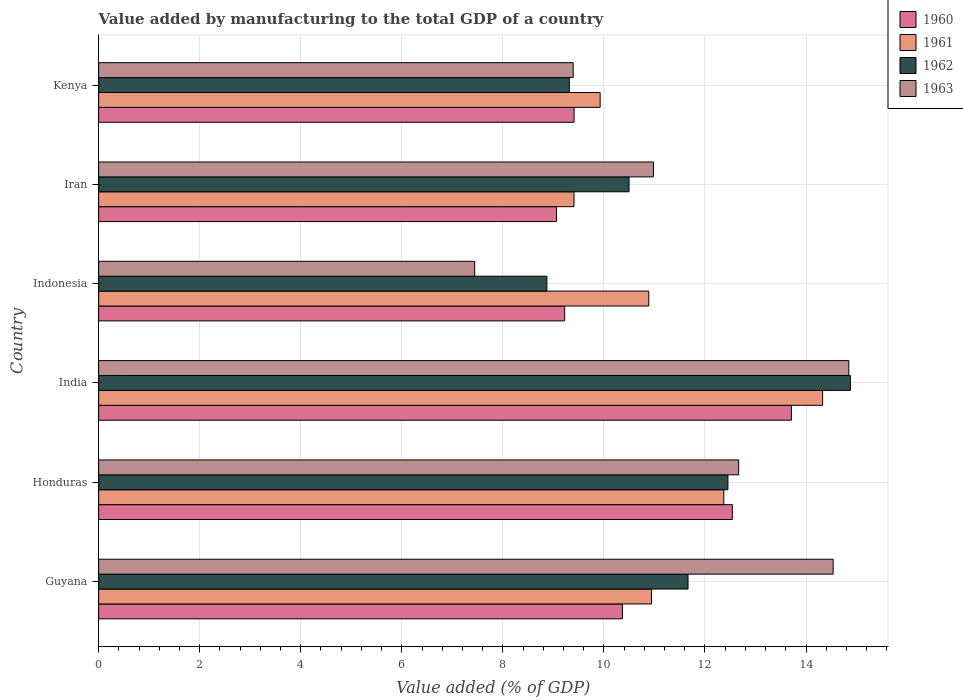How many different coloured bars are there?
Provide a short and direct response. 4. Are the number of bars per tick equal to the number of legend labels?
Offer a terse response. Yes. Are the number of bars on each tick of the Y-axis equal?
Provide a succinct answer. Yes. How many bars are there on the 6th tick from the bottom?
Your response must be concise. 4. What is the label of the 6th group of bars from the top?
Keep it short and to the point. Guyana. What is the value added by manufacturing to the total GDP in 1960 in Iran?
Your response must be concise. 9.06. Across all countries, what is the maximum value added by manufacturing to the total GDP in 1962?
Your answer should be very brief. 14.88. Across all countries, what is the minimum value added by manufacturing to the total GDP in 1961?
Your response must be concise. 9.41. In which country was the value added by manufacturing to the total GDP in 1961 maximum?
Make the answer very short. India. In which country was the value added by manufacturing to the total GDP in 1960 minimum?
Offer a terse response. Iran. What is the total value added by manufacturing to the total GDP in 1961 in the graph?
Provide a succinct answer. 67.86. What is the difference between the value added by manufacturing to the total GDP in 1961 in Honduras and that in Kenya?
Give a very brief answer. 2.45. What is the difference between the value added by manufacturing to the total GDP in 1960 in Kenya and the value added by manufacturing to the total GDP in 1962 in Iran?
Provide a succinct answer. -1.09. What is the average value added by manufacturing to the total GDP in 1962 per country?
Keep it short and to the point. 11.28. What is the difference between the value added by manufacturing to the total GDP in 1961 and value added by manufacturing to the total GDP in 1963 in India?
Offer a very short reply. -0.52. In how many countries, is the value added by manufacturing to the total GDP in 1962 greater than 8.4 %?
Provide a succinct answer. 6. What is the ratio of the value added by manufacturing to the total GDP in 1960 in India to that in Kenya?
Your answer should be compact. 1.46. Is the difference between the value added by manufacturing to the total GDP in 1961 in Honduras and India greater than the difference between the value added by manufacturing to the total GDP in 1963 in Honduras and India?
Offer a very short reply. Yes. What is the difference between the highest and the second highest value added by manufacturing to the total GDP in 1960?
Your answer should be very brief. 1.17. What is the difference between the highest and the lowest value added by manufacturing to the total GDP in 1961?
Provide a short and direct response. 4.92. Is the sum of the value added by manufacturing to the total GDP in 1960 in Guyana and Iran greater than the maximum value added by manufacturing to the total GDP in 1963 across all countries?
Provide a succinct answer. Yes. What does the 4th bar from the top in Guyana represents?
Provide a short and direct response. 1960. How many countries are there in the graph?
Ensure brevity in your answer.  6. What is the difference between two consecutive major ticks on the X-axis?
Provide a short and direct response. 2. Does the graph contain any zero values?
Provide a short and direct response. No. How many legend labels are there?
Make the answer very short. 4. How are the legend labels stacked?
Your answer should be very brief. Vertical. What is the title of the graph?
Give a very brief answer. Value added by manufacturing to the total GDP of a country. Does "2007" appear as one of the legend labels in the graph?
Make the answer very short. No. What is the label or title of the X-axis?
Your response must be concise. Value added (% of GDP). What is the label or title of the Y-axis?
Give a very brief answer. Country. What is the Value added (% of GDP) in 1960 in Guyana?
Your answer should be very brief. 10.37. What is the Value added (% of GDP) in 1961 in Guyana?
Your answer should be very brief. 10.94. What is the Value added (% of GDP) in 1962 in Guyana?
Provide a succinct answer. 11.66. What is the Value added (% of GDP) in 1963 in Guyana?
Provide a short and direct response. 14.54. What is the Value added (% of GDP) of 1960 in Honduras?
Ensure brevity in your answer.  12.54. What is the Value added (% of GDP) of 1961 in Honduras?
Give a very brief answer. 12.37. What is the Value added (% of GDP) of 1962 in Honduras?
Ensure brevity in your answer.  12.45. What is the Value added (% of GDP) of 1963 in Honduras?
Give a very brief answer. 12.67. What is the Value added (% of GDP) of 1960 in India?
Keep it short and to the point. 13.71. What is the Value added (% of GDP) in 1961 in India?
Give a very brief answer. 14.33. What is the Value added (% of GDP) in 1962 in India?
Provide a succinct answer. 14.88. What is the Value added (% of GDP) in 1963 in India?
Your answer should be very brief. 14.85. What is the Value added (% of GDP) in 1960 in Indonesia?
Make the answer very short. 9.22. What is the Value added (% of GDP) in 1961 in Indonesia?
Give a very brief answer. 10.89. What is the Value added (% of GDP) in 1962 in Indonesia?
Your response must be concise. 8.87. What is the Value added (% of GDP) of 1963 in Indonesia?
Ensure brevity in your answer.  7.44. What is the Value added (% of GDP) of 1960 in Iran?
Provide a succinct answer. 9.06. What is the Value added (% of GDP) in 1961 in Iran?
Ensure brevity in your answer.  9.41. What is the Value added (% of GDP) in 1962 in Iran?
Ensure brevity in your answer.  10.5. What is the Value added (% of GDP) in 1963 in Iran?
Offer a terse response. 10.98. What is the Value added (% of GDP) in 1960 in Kenya?
Your answer should be compact. 9.41. What is the Value added (% of GDP) of 1961 in Kenya?
Offer a terse response. 9.93. What is the Value added (% of GDP) of 1962 in Kenya?
Offer a very short reply. 9.32. What is the Value added (% of GDP) in 1963 in Kenya?
Keep it short and to the point. 9.39. Across all countries, what is the maximum Value added (% of GDP) of 1960?
Your response must be concise. 13.71. Across all countries, what is the maximum Value added (% of GDP) in 1961?
Ensure brevity in your answer.  14.33. Across all countries, what is the maximum Value added (% of GDP) of 1962?
Your answer should be compact. 14.88. Across all countries, what is the maximum Value added (% of GDP) of 1963?
Give a very brief answer. 14.85. Across all countries, what is the minimum Value added (% of GDP) in 1960?
Keep it short and to the point. 9.06. Across all countries, what is the minimum Value added (% of GDP) in 1961?
Your response must be concise. 9.41. Across all countries, what is the minimum Value added (% of GDP) of 1962?
Provide a short and direct response. 8.87. Across all countries, what is the minimum Value added (% of GDP) of 1963?
Provide a short and direct response. 7.44. What is the total Value added (% of GDP) in 1960 in the graph?
Ensure brevity in your answer.  64.31. What is the total Value added (% of GDP) of 1961 in the graph?
Your answer should be compact. 67.86. What is the total Value added (% of GDP) in 1962 in the graph?
Give a very brief answer. 67.68. What is the total Value added (% of GDP) in 1963 in the graph?
Offer a terse response. 69.86. What is the difference between the Value added (% of GDP) of 1960 in Guyana and that in Honduras?
Your response must be concise. -2.18. What is the difference between the Value added (% of GDP) of 1961 in Guyana and that in Honduras?
Provide a succinct answer. -1.43. What is the difference between the Value added (% of GDP) in 1962 in Guyana and that in Honduras?
Offer a terse response. -0.79. What is the difference between the Value added (% of GDP) of 1963 in Guyana and that in Honduras?
Offer a very short reply. 1.87. What is the difference between the Value added (% of GDP) of 1960 in Guyana and that in India?
Give a very brief answer. -3.34. What is the difference between the Value added (% of GDP) in 1961 in Guyana and that in India?
Your response must be concise. -3.39. What is the difference between the Value added (% of GDP) in 1962 in Guyana and that in India?
Give a very brief answer. -3.21. What is the difference between the Value added (% of GDP) of 1963 in Guyana and that in India?
Your answer should be compact. -0.31. What is the difference between the Value added (% of GDP) in 1960 in Guyana and that in Indonesia?
Offer a terse response. 1.14. What is the difference between the Value added (% of GDP) of 1961 in Guyana and that in Indonesia?
Your response must be concise. 0.05. What is the difference between the Value added (% of GDP) in 1962 in Guyana and that in Indonesia?
Your answer should be very brief. 2.79. What is the difference between the Value added (% of GDP) of 1963 in Guyana and that in Indonesia?
Ensure brevity in your answer.  7.09. What is the difference between the Value added (% of GDP) of 1960 in Guyana and that in Iran?
Keep it short and to the point. 1.3. What is the difference between the Value added (% of GDP) in 1961 in Guyana and that in Iran?
Your answer should be compact. 1.53. What is the difference between the Value added (% of GDP) of 1962 in Guyana and that in Iran?
Ensure brevity in your answer.  1.17. What is the difference between the Value added (% of GDP) of 1963 in Guyana and that in Iran?
Your answer should be very brief. 3.56. What is the difference between the Value added (% of GDP) in 1960 in Guyana and that in Kenya?
Provide a succinct answer. 0.96. What is the difference between the Value added (% of GDP) of 1961 in Guyana and that in Kenya?
Provide a succinct answer. 1.02. What is the difference between the Value added (% of GDP) of 1962 in Guyana and that in Kenya?
Offer a terse response. 2.35. What is the difference between the Value added (% of GDP) in 1963 in Guyana and that in Kenya?
Your response must be concise. 5.14. What is the difference between the Value added (% of GDP) in 1960 in Honduras and that in India?
Your answer should be very brief. -1.17. What is the difference between the Value added (% of GDP) in 1961 in Honduras and that in India?
Your response must be concise. -1.96. What is the difference between the Value added (% of GDP) in 1962 in Honduras and that in India?
Your response must be concise. -2.42. What is the difference between the Value added (% of GDP) of 1963 in Honduras and that in India?
Provide a short and direct response. -2.18. What is the difference between the Value added (% of GDP) of 1960 in Honduras and that in Indonesia?
Make the answer very short. 3.32. What is the difference between the Value added (% of GDP) in 1961 in Honduras and that in Indonesia?
Keep it short and to the point. 1.49. What is the difference between the Value added (% of GDP) of 1962 in Honduras and that in Indonesia?
Offer a very short reply. 3.58. What is the difference between the Value added (% of GDP) in 1963 in Honduras and that in Indonesia?
Provide a succinct answer. 5.22. What is the difference between the Value added (% of GDP) of 1960 in Honduras and that in Iran?
Your answer should be compact. 3.48. What is the difference between the Value added (% of GDP) in 1961 in Honduras and that in Iran?
Your answer should be very brief. 2.96. What is the difference between the Value added (% of GDP) in 1962 in Honduras and that in Iran?
Make the answer very short. 1.96. What is the difference between the Value added (% of GDP) of 1963 in Honduras and that in Iran?
Make the answer very short. 1.69. What is the difference between the Value added (% of GDP) in 1960 in Honduras and that in Kenya?
Your answer should be very brief. 3.13. What is the difference between the Value added (% of GDP) in 1961 in Honduras and that in Kenya?
Make the answer very short. 2.45. What is the difference between the Value added (% of GDP) in 1962 in Honduras and that in Kenya?
Offer a terse response. 3.14. What is the difference between the Value added (% of GDP) of 1963 in Honduras and that in Kenya?
Offer a very short reply. 3.27. What is the difference between the Value added (% of GDP) in 1960 in India and that in Indonesia?
Provide a short and direct response. 4.49. What is the difference between the Value added (% of GDP) in 1961 in India and that in Indonesia?
Keep it short and to the point. 3.44. What is the difference between the Value added (% of GDP) of 1962 in India and that in Indonesia?
Offer a terse response. 6.01. What is the difference between the Value added (% of GDP) of 1963 in India and that in Indonesia?
Your answer should be compact. 7.4. What is the difference between the Value added (% of GDP) in 1960 in India and that in Iran?
Provide a succinct answer. 4.65. What is the difference between the Value added (% of GDP) in 1961 in India and that in Iran?
Make the answer very short. 4.92. What is the difference between the Value added (% of GDP) in 1962 in India and that in Iran?
Provide a succinct answer. 4.38. What is the difference between the Value added (% of GDP) of 1963 in India and that in Iran?
Make the answer very short. 3.87. What is the difference between the Value added (% of GDP) of 1960 in India and that in Kenya?
Your answer should be compact. 4.3. What is the difference between the Value added (% of GDP) of 1961 in India and that in Kenya?
Ensure brevity in your answer.  4.4. What is the difference between the Value added (% of GDP) of 1962 in India and that in Kenya?
Your answer should be compact. 5.56. What is the difference between the Value added (% of GDP) in 1963 in India and that in Kenya?
Your response must be concise. 5.45. What is the difference between the Value added (% of GDP) of 1960 in Indonesia and that in Iran?
Your answer should be very brief. 0.16. What is the difference between the Value added (% of GDP) of 1961 in Indonesia and that in Iran?
Keep it short and to the point. 1.48. What is the difference between the Value added (% of GDP) in 1962 in Indonesia and that in Iran?
Provide a succinct answer. -1.63. What is the difference between the Value added (% of GDP) of 1963 in Indonesia and that in Iran?
Make the answer very short. -3.54. What is the difference between the Value added (% of GDP) of 1960 in Indonesia and that in Kenya?
Provide a succinct answer. -0.19. What is the difference between the Value added (% of GDP) in 1961 in Indonesia and that in Kenya?
Provide a short and direct response. 0.96. What is the difference between the Value added (% of GDP) of 1962 in Indonesia and that in Kenya?
Give a very brief answer. -0.44. What is the difference between the Value added (% of GDP) of 1963 in Indonesia and that in Kenya?
Offer a very short reply. -1.95. What is the difference between the Value added (% of GDP) of 1960 in Iran and that in Kenya?
Provide a short and direct response. -0.35. What is the difference between the Value added (% of GDP) of 1961 in Iran and that in Kenya?
Make the answer very short. -0.52. What is the difference between the Value added (% of GDP) of 1962 in Iran and that in Kenya?
Keep it short and to the point. 1.18. What is the difference between the Value added (% of GDP) in 1963 in Iran and that in Kenya?
Give a very brief answer. 1.59. What is the difference between the Value added (% of GDP) in 1960 in Guyana and the Value added (% of GDP) in 1961 in Honduras?
Make the answer very short. -2.01. What is the difference between the Value added (% of GDP) of 1960 in Guyana and the Value added (% of GDP) of 1962 in Honduras?
Your answer should be very brief. -2.09. What is the difference between the Value added (% of GDP) of 1960 in Guyana and the Value added (% of GDP) of 1963 in Honduras?
Your answer should be very brief. -2.3. What is the difference between the Value added (% of GDP) of 1961 in Guyana and the Value added (% of GDP) of 1962 in Honduras?
Provide a short and direct response. -1.51. What is the difference between the Value added (% of GDP) in 1961 in Guyana and the Value added (% of GDP) in 1963 in Honduras?
Offer a terse response. -1.73. What is the difference between the Value added (% of GDP) in 1962 in Guyana and the Value added (% of GDP) in 1963 in Honduras?
Offer a terse response. -1. What is the difference between the Value added (% of GDP) in 1960 in Guyana and the Value added (% of GDP) in 1961 in India?
Provide a succinct answer. -3.96. What is the difference between the Value added (% of GDP) of 1960 in Guyana and the Value added (% of GDP) of 1962 in India?
Ensure brevity in your answer.  -4.51. What is the difference between the Value added (% of GDP) of 1960 in Guyana and the Value added (% of GDP) of 1963 in India?
Your response must be concise. -4.48. What is the difference between the Value added (% of GDP) of 1961 in Guyana and the Value added (% of GDP) of 1962 in India?
Provide a short and direct response. -3.94. What is the difference between the Value added (% of GDP) in 1961 in Guyana and the Value added (% of GDP) in 1963 in India?
Your answer should be very brief. -3.91. What is the difference between the Value added (% of GDP) in 1962 in Guyana and the Value added (% of GDP) in 1963 in India?
Provide a succinct answer. -3.18. What is the difference between the Value added (% of GDP) in 1960 in Guyana and the Value added (% of GDP) in 1961 in Indonesia?
Give a very brief answer. -0.52. What is the difference between the Value added (% of GDP) in 1960 in Guyana and the Value added (% of GDP) in 1962 in Indonesia?
Provide a short and direct response. 1.49. What is the difference between the Value added (% of GDP) in 1960 in Guyana and the Value added (% of GDP) in 1963 in Indonesia?
Offer a terse response. 2.92. What is the difference between the Value added (% of GDP) of 1961 in Guyana and the Value added (% of GDP) of 1962 in Indonesia?
Provide a short and direct response. 2.07. What is the difference between the Value added (% of GDP) of 1961 in Guyana and the Value added (% of GDP) of 1963 in Indonesia?
Your answer should be very brief. 3.5. What is the difference between the Value added (% of GDP) in 1962 in Guyana and the Value added (% of GDP) in 1963 in Indonesia?
Provide a short and direct response. 4.22. What is the difference between the Value added (% of GDP) of 1960 in Guyana and the Value added (% of GDP) of 1961 in Iran?
Provide a succinct answer. 0.96. What is the difference between the Value added (% of GDP) in 1960 in Guyana and the Value added (% of GDP) in 1962 in Iran?
Offer a very short reply. -0.13. What is the difference between the Value added (% of GDP) of 1960 in Guyana and the Value added (% of GDP) of 1963 in Iran?
Provide a short and direct response. -0.61. What is the difference between the Value added (% of GDP) of 1961 in Guyana and the Value added (% of GDP) of 1962 in Iran?
Offer a terse response. 0.44. What is the difference between the Value added (% of GDP) in 1961 in Guyana and the Value added (% of GDP) in 1963 in Iran?
Your answer should be very brief. -0.04. What is the difference between the Value added (% of GDP) of 1962 in Guyana and the Value added (% of GDP) of 1963 in Iran?
Keep it short and to the point. 0.68. What is the difference between the Value added (% of GDP) of 1960 in Guyana and the Value added (% of GDP) of 1961 in Kenya?
Offer a very short reply. 0.44. What is the difference between the Value added (% of GDP) of 1960 in Guyana and the Value added (% of GDP) of 1962 in Kenya?
Make the answer very short. 1.05. What is the difference between the Value added (% of GDP) of 1960 in Guyana and the Value added (% of GDP) of 1963 in Kenya?
Your answer should be very brief. 0.97. What is the difference between the Value added (% of GDP) of 1961 in Guyana and the Value added (% of GDP) of 1962 in Kenya?
Ensure brevity in your answer.  1.63. What is the difference between the Value added (% of GDP) in 1961 in Guyana and the Value added (% of GDP) in 1963 in Kenya?
Make the answer very short. 1.55. What is the difference between the Value added (% of GDP) in 1962 in Guyana and the Value added (% of GDP) in 1963 in Kenya?
Give a very brief answer. 2.27. What is the difference between the Value added (% of GDP) in 1960 in Honduras and the Value added (% of GDP) in 1961 in India?
Provide a succinct answer. -1.79. What is the difference between the Value added (% of GDP) in 1960 in Honduras and the Value added (% of GDP) in 1962 in India?
Your answer should be very brief. -2.34. What is the difference between the Value added (% of GDP) of 1960 in Honduras and the Value added (% of GDP) of 1963 in India?
Give a very brief answer. -2.31. What is the difference between the Value added (% of GDP) in 1961 in Honduras and the Value added (% of GDP) in 1962 in India?
Your answer should be very brief. -2.51. What is the difference between the Value added (% of GDP) in 1961 in Honduras and the Value added (% of GDP) in 1963 in India?
Keep it short and to the point. -2.47. What is the difference between the Value added (% of GDP) of 1962 in Honduras and the Value added (% of GDP) of 1963 in India?
Keep it short and to the point. -2.39. What is the difference between the Value added (% of GDP) in 1960 in Honduras and the Value added (% of GDP) in 1961 in Indonesia?
Offer a terse response. 1.65. What is the difference between the Value added (% of GDP) of 1960 in Honduras and the Value added (% of GDP) of 1962 in Indonesia?
Give a very brief answer. 3.67. What is the difference between the Value added (% of GDP) of 1960 in Honduras and the Value added (% of GDP) of 1963 in Indonesia?
Provide a short and direct response. 5.1. What is the difference between the Value added (% of GDP) of 1961 in Honduras and the Value added (% of GDP) of 1962 in Indonesia?
Offer a very short reply. 3.5. What is the difference between the Value added (% of GDP) of 1961 in Honduras and the Value added (% of GDP) of 1963 in Indonesia?
Your response must be concise. 4.93. What is the difference between the Value added (% of GDP) of 1962 in Honduras and the Value added (% of GDP) of 1963 in Indonesia?
Keep it short and to the point. 5.01. What is the difference between the Value added (% of GDP) of 1960 in Honduras and the Value added (% of GDP) of 1961 in Iran?
Your answer should be compact. 3.13. What is the difference between the Value added (% of GDP) in 1960 in Honduras and the Value added (% of GDP) in 1962 in Iran?
Your answer should be very brief. 2.04. What is the difference between the Value added (% of GDP) of 1960 in Honduras and the Value added (% of GDP) of 1963 in Iran?
Offer a terse response. 1.56. What is the difference between the Value added (% of GDP) of 1961 in Honduras and the Value added (% of GDP) of 1962 in Iran?
Make the answer very short. 1.88. What is the difference between the Value added (% of GDP) in 1961 in Honduras and the Value added (% of GDP) in 1963 in Iran?
Your answer should be compact. 1.39. What is the difference between the Value added (% of GDP) in 1962 in Honduras and the Value added (% of GDP) in 1963 in Iran?
Make the answer very short. 1.47. What is the difference between the Value added (% of GDP) in 1960 in Honduras and the Value added (% of GDP) in 1961 in Kenya?
Ensure brevity in your answer.  2.62. What is the difference between the Value added (% of GDP) of 1960 in Honduras and the Value added (% of GDP) of 1962 in Kenya?
Provide a succinct answer. 3.23. What is the difference between the Value added (% of GDP) in 1960 in Honduras and the Value added (% of GDP) in 1963 in Kenya?
Offer a very short reply. 3.15. What is the difference between the Value added (% of GDP) in 1961 in Honduras and the Value added (% of GDP) in 1962 in Kenya?
Keep it short and to the point. 3.06. What is the difference between the Value added (% of GDP) in 1961 in Honduras and the Value added (% of GDP) in 1963 in Kenya?
Ensure brevity in your answer.  2.98. What is the difference between the Value added (% of GDP) of 1962 in Honduras and the Value added (% of GDP) of 1963 in Kenya?
Your response must be concise. 3.06. What is the difference between the Value added (% of GDP) of 1960 in India and the Value added (% of GDP) of 1961 in Indonesia?
Provide a short and direct response. 2.82. What is the difference between the Value added (% of GDP) of 1960 in India and the Value added (% of GDP) of 1962 in Indonesia?
Your answer should be very brief. 4.84. What is the difference between the Value added (% of GDP) in 1960 in India and the Value added (% of GDP) in 1963 in Indonesia?
Give a very brief answer. 6.27. What is the difference between the Value added (% of GDP) in 1961 in India and the Value added (% of GDP) in 1962 in Indonesia?
Offer a terse response. 5.46. What is the difference between the Value added (% of GDP) in 1961 in India and the Value added (% of GDP) in 1963 in Indonesia?
Keep it short and to the point. 6.89. What is the difference between the Value added (% of GDP) of 1962 in India and the Value added (% of GDP) of 1963 in Indonesia?
Your response must be concise. 7.44. What is the difference between the Value added (% of GDP) of 1960 in India and the Value added (% of GDP) of 1961 in Iran?
Your response must be concise. 4.3. What is the difference between the Value added (% of GDP) of 1960 in India and the Value added (% of GDP) of 1962 in Iran?
Make the answer very short. 3.21. What is the difference between the Value added (% of GDP) of 1960 in India and the Value added (% of GDP) of 1963 in Iran?
Provide a short and direct response. 2.73. What is the difference between the Value added (% of GDP) of 1961 in India and the Value added (% of GDP) of 1962 in Iran?
Your answer should be compact. 3.83. What is the difference between the Value added (% of GDP) of 1961 in India and the Value added (% of GDP) of 1963 in Iran?
Provide a short and direct response. 3.35. What is the difference between the Value added (% of GDP) of 1962 in India and the Value added (% of GDP) of 1963 in Iran?
Offer a very short reply. 3.9. What is the difference between the Value added (% of GDP) of 1960 in India and the Value added (% of GDP) of 1961 in Kenya?
Offer a terse response. 3.78. What is the difference between the Value added (% of GDP) of 1960 in India and the Value added (% of GDP) of 1962 in Kenya?
Offer a terse response. 4.39. What is the difference between the Value added (% of GDP) of 1960 in India and the Value added (% of GDP) of 1963 in Kenya?
Offer a terse response. 4.32. What is the difference between the Value added (% of GDP) in 1961 in India and the Value added (% of GDP) in 1962 in Kenya?
Make the answer very short. 5.01. What is the difference between the Value added (% of GDP) of 1961 in India and the Value added (% of GDP) of 1963 in Kenya?
Keep it short and to the point. 4.94. What is the difference between the Value added (% of GDP) in 1962 in India and the Value added (% of GDP) in 1963 in Kenya?
Provide a short and direct response. 5.49. What is the difference between the Value added (% of GDP) of 1960 in Indonesia and the Value added (% of GDP) of 1961 in Iran?
Your response must be concise. -0.18. What is the difference between the Value added (% of GDP) in 1960 in Indonesia and the Value added (% of GDP) in 1962 in Iran?
Provide a succinct answer. -1.27. What is the difference between the Value added (% of GDP) of 1960 in Indonesia and the Value added (% of GDP) of 1963 in Iran?
Your answer should be very brief. -1.76. What is the difference between the Value added (% of GDP) of 1961 in Indonesia and the Value added (% of GDP) of 1962 in Iran?
Give a very brief answer. 0.39. What is the difference between the Value added (% of GDP) of 1961 in Indonesia and the Value added (% of GDP) of 1963 in Iran?
Keep it short and to the point. -0.09. What is the difference between the Value added (% of GDP) of 1962 in Indonesia and the Value added (% of GDP) of 1963 in Iran?
Offer a very short reply. -2.11. What is the difference between the Value added (% of GDP) in 1960 in Indonesia and the Value added (% of GDP) in 1961 in Kenya?
Your response must be concise. -0.7. What is the difference between the Value added (% of GDP) in 1960 in Indonesia and the Value added (% of GDP) in 1962 in Kenya?
Provide a short and direct response. -0.09. What is the difference between the Value added (% of GDP) of 1960 in Indonesia and the Value added (% of GDP) of 1963 in Kenya?
Offer a terse response. -0.17. What is the difference between the Value added (% of GDP) in 1961 in Indonesia and the Value added (% of GDP) in 1962 in Kenya?
Offer a very short reply. 1.57. What is the difference between the Value added (% of GDP) in 1961 in Indonesia and the Value added (% of GDP) in 1963 in Kenya?
Ensure brevity in your answer.  1.5. What is the difference between the Value added (% of GDP) of 1962 in Indonesia and the Value added (% of GDP) of 1963 in Kenya?
Provide a short and direct response. -0.52. What is the difference between the Value added (% of GDP) in 1960 in Iran and the Value added (% of GDP) in 1961 in Kenya?
Your answer should be compact. -0.86. What is the difference between the Value added (% of GDP) of 1960 in Iran and the Value added (% of GDP) of 1962 in Kenya?
Provide a short and direct response. -0.25. What is the difference between the Value added (% of GDP) of 1960 in Iran and the Value added (% of GDP) of 1963 in Kenya?
Your answer should be compact. -0.33. What is the difference between the Value added (% of GDP) of 1961 in Iran and the Value added (% of GDP) of 1962 in Kenya?
Provide a succinct answer. 0.09. What is the difference between the Value added (% of GDP) of 1961 in Iran and the Value added (% of GDP) of 1963 in Kenya?
Your answer should be very brief. 0.02. What is the difference between the Value added (% of GDP) in 1962 in Iran and the Value added (% of GDP) in 1963 in Kenya?
Ensure brevity in your answer.  1.11. What is the average Value added (% of GDP) of 1960 per country?
Give a very brief answer. 10.72. What is the average Value added (% of GDP) in 1961 per country?
Offer a very short reply. 11.31. What is the average Value added (% of GDP) of 1962 per country?
Make the answer very short. 11.28. What is the average Value added (% of GDP) of 1963 per country?
Your answer should be very brief. 11.64. What is the difference between the Value added (% of GDP) of 1960 and Value added (% of GDP) of 1961 in Guyana?
Make the answer very short. -0.58. What is the difference between the Value added (% of GDP) of 1960 and Value added (% of GDP) of 1962 in Guyana?
Offer a very short reply. -1.3. What is the difference between the Value added (% of GDP) in 1960 and Value added (% of GDP) in 1963 in Guyana?
Your answer should be very brief. -4.17. What is the difference between the Value added (% of GDP) of 1961 and Value added (% of GDP) of 1962 in Guyana?
Your answer should be compact. -0.72. What is the difference between the Value added (% of GDP) of 1961 and Value added (% of GDP) of 1963 in Guyana?
Make the answer very short. -3.6. What is the difference between the Value added (% of GDP) in 1962 and Value added (% of GDP) in 1963 in Guyana?
Your answer should be very brief. -2.87. What is the difference between the Value added (% of GDP) of 1960 and Value added (% of GDP) of 1961 in Honduras?
Make the answer very short. 0.17. What is the difference between the Value added (% of GDP) of 1960 and Value added (% of GDP) of 1962 in Honduras?
Offer a terse response. 0.09. What is the difference between the Value added (% of GDP) in 1960 and Value added (% of GDP) in 1963 in Honduras?
Make the answer very short. -0.13. What is the difference between the Value added (% of GDP) of 1961 and Value added (% of GDP) of 1962 in Honduras?
Offer a very short reply. -0.08. What is the difference between the Value added (% of GDP) in 1961 and Value added (% of GDP) in 1963 in Honduras?
Provide a succinct answer. -0.29. What is the difference between the Value added (% of GDP) of 1962 and Value added (% of GDP) of 1963 in Honduras?
Your answer should be very brief. -0.21. What is the difference between the Value added (% of GDP) in 1960 and Value added (% of GDP) in 1961 in India?
Your answer should be very brief. -0.62. What is the difference between the Value added (% of GDP) of 1960 and Value added (% of GDP) of 1962 in India?
Your answer should be very brief. -1.17. What is the difference between the Value added (% of GDP) of 1960 and Value added (% of GDP) of 1963 in India?
Ensure brevity in your answer.  -1.14. What is the difference between the Value added (% of GDP) of 1961 and Value added (% of GDP) of 1962 in India?
Provide a succinct answer. -0.55. What is the difference between the Value added (% of GDP) of 1961 and Value added (% of GDP) of 1963 in India?
Keep it short and to the point. -0.52. What is the difference between the Value added (% of GDP) in 1962 and Value added (% of GDP) in 1963 in India?
Ensure brevity in your answer.  0.03. What is the difference between the Value added (% of GDP) of 1960 and Value added (% of GDP) of 1961 in Indonesia?
Offer a terse response. -1.66. What is the difference between the Value added (% of GDP) in 1960 and Value added (% of GDP) in 1962 in Indonesia?
Give a very brief answer. 0.35. What is the difference between the Value added (% of GDP) in 1960 and Value added (% of GDP) in 1963 in Indonesia?
Keep it short and to the point. 1.78. What is the difference between the Value added (% of GDP) of 1961 and Value added (% of GDP) of 1962 in Indonesia?
Provide a succinct answer. 2.02. What is the difference between the Value added (% of GDP) of 1961 and Value added (% of GDP) of 1963 in Indonesia?
Your answer should be compact. 3.44. What is the difference between the Value added (% of GDP) of 1962 and Value added (% of GDP) of 1963 in Indonesia?
Ensure brevity in your answer.  1.43. What is the difference between the Value added (% of GDP) of 1960 and Value added (% of GDP) of 1961 in Iran?
Your answer should be very brief. -0.35. What is the difference between the Value added (% of GDP) in 1960 and Value added (% of GDP) in 1962 in Iran?
Offer a very short reply. -1.44. What is the difference between the Value added (% of GDP) in 1960 and Value added (% of GDP) in 1963 in Iran?
Give a very brief answer. -1.92. What is the difference between the Value added (% of GDP) in 1961 and Value added (% of GDP) in 1962 in Iran?
Your answer should be very brief. -1.09. What is the difference between the Value added (% of GDP) of 1961 and Value added (% of GDP) of 1963 in Iran?
Provide a succinct answer. -1.57. What is the difference between the Value added (% of GDP) of 1962 and Value added (% of GDP) of 1963 in Iran?
Keep it short and to the point. -0.48. What is the difference between the Value added (% of GDP) of 1960 and Value added (% of GDP) of 1961 in Kenya?
Give a very brief answer. -0.52. What is the difference between the Value added (% of GDP) in 1960 and Value added (% of GDP) in 1962 in Kenya?
Provide a succinct answer. 0.09. What is the difference between the Value added (% of GDP) of 1960 and Value added (% of GDP) of 1963 in Kenya?
Offer a terse response. 0.02. What is the difference between the Value added (% of GDP) in 1961 and Value added (% of GDP) in 1962 in Kenya?
Provide a short and direct response. 0.61. What is the difference between the Value added (% of GDP) in 1961 and Value added (% of GDP) in 1963 in Kenya?
Offer a very short reply. 0.53. What is the difference between the Value added (% of GDP) of 1962 and Value added (% of GDP) of 1963 in Kenya?
Offer a very short reply. -0.08. What is the ratio of the Value added (% of GDP) of 1960 in Guyana to that in Honduras?
Your answer should be compact. 0.83. What is the ratio of the Value added (% of GDP) of 1961 in Guyana to that in Honduras?
Give a very brief answer. 0.88. What is the ratio of the Value added (% of GDP) of 1962 in Guyana to that in Honduras?
Your answer should be very brief. 0.94. What is the ratio of the Value added (% of GDP) in 1963 in Guyana to that in Honduras?
Provide a short and direct response. 1.15. What is the ratio of the Value added (% of GDP) in 1960 in Guyana to that in India?
Offer a terse response. 0.76. What is the ratio of the Value added (% of GDP) in 1961 in Guyana to that in India?
Make the answer very short. 0.76. What is the ratio of the Value added (% of GDP) in 1962 in Guyana to that in India?
Your answer should be compact. 0.78. What is the ratio of the Value added (% of GDP) of 1963 in Guyana to that in India?
Ensure brevity in your answer.  0.98. What is the ratio of the Value added (% of GDP) in 1960 in Guyana to that in Indonesia?
Offer a very short reply. 1.12. What is the ratio of the Value added (% of GDP) in 1962 in Guyana to that in Indonesia?
Your answer should be compact. 1.31. What is the ratio of the Value added (% of GDP) of 1963 in Guyana to that in Indonesia?
Your answer should be very brief. 1.95. What is the ratio of the Value added (% of GDP) of 1960 in Guyana to that in Iran?
Your answer should be compact. 1.14. What is the ratio of the Value added (% of GDP) of 1961 in Guyana to that in Iran?
Ensure brevity in your answer.  1.16. What is the ratio of the Value added (% of GDP) of 1962 in Guyana to that in Iran?
Provide a succinct answer. 1.11. What is the ratio of the Value added (% of GDP) of 1963 in Guyana to that in Iran?
Offer a very short reply. 1.32. What is the ratio of the Value added (% of GDP) in 1960 in Guyana to that in Kenya?
Offer a very short reply. 1.1. What is the ratio of the Value added (% of GDP) of 1961 in Guyana to that in Kenya?
Offer a terse response. 1.1. What is the ratio of the Value added (% of GDP) in 1962 in Guyana to that in Kenya?
Offer a terse response. 1.25. What is the ratio of the Value added (% of GDP) in 1963 in Guyana to that in Kenya?
Provide a short and direct response. 1.55. What is the ratio of the Value added (% of GDP) of 1960 in Honduras to that in India?
Your answer should be compact. 0.91. What is the ratio of the Value added (% of GDP) in 1961 in Honduras to that in India?
Give a very brief answer. 0.86. What is the ratio of the Value added (% of GDP) in 1962 in Honduras to that in India?
Provide a short and direct response. 0.84. What is the ratio of the Value added (% of GDP) in 1963 in Honduras to that in India?
Provide a succinct answer. 0.85. What is the ratio of the Value added (% of GDP) of 1960 in Honduras to that in Indonesia?
Your answer should be very brief. 1.36. What is the ratio of the Value added (% of GDP) of 1961 in Honduras to that in Indonesia?
Keep it short and to the point. 1.14. What is the ratio of the Value added (% of GDP) of 1962 in Honduras to that in Indonesia?
Make the answer very short. 1.4. What is the ratio of the Value added (% of GDP) of 1963 in Honduras to that in Indonesia?
Your answer should be compact. 1.7. What is the ratio of the Value added (% of GDP) in 1960 in Honduras to that in Iran?
Ensure brevity in your answer.  1.38. What is the ratio of the Value added (% of GDP) of 1961 in Honduras to that in Iran?
Your response must be concise. 1.32. What is the ratio of the Value added (% of GDP) of 1962 in Honduras to that in Iran?
Provide a short and direct response. 1.19. What is the ratio of the Value added (% of GDP) in 1963 in Honduras to that in Iran?
Give a very brief answer. 1.15. What is the ratio of the Value added (% of GDP) in 1960 in Honduras to that in Kenya?
Your answer should be very brief. 1.33. What is the ratio of the Value added (% of GDP) in 1961 in Honduras to that in Kenya?
Your answer should be compact. 1.25. What is the ratio of the Value added (% of GDP) in 1962 in Honduras to that in Kenya?
Your response must be concise. 1.34. What is the ratio of the Value added (% of GDP) of 1963 in Honduras to that in Kenya?
Your answer should be very brief. 1.35. What is the ratio of the Value added (% of GDP) of 1960 in India to that in Indonesia?
Your response must be concise. 1.49. What is the ratio of the Value added (% of GDP) in 1961 in India to that in Indonesia?
Provide a short and direct response. 1.32. What is the ratio of the Value added (% of GDP) of 1962 in India to that in Indonesia?
Give a very brief answer. 1.68. What is the ratio of the Value added (% of GDP) in 1963 in India to that in Indonesia?
Your response must be concise. 1.99. What is the ratio of the Value added (% of GDP) of 1960 in India to that in Iran?
Offer a terse response. 1.51. What is the ratio of the Value added (% of GDP) of 1961 in India to that in Iran?
Your answer should be very brief. 1.52. What is the ratio of the Value added (% of GDP) of 1962 in India to that in Iran?
Provide a succinct answer. 1.42. What is the ratio of the Value added (% of GDP) in 1963 in India to that in Iran?
Ensure brevity in your answer.  1.35. What is the ratio of the Value added (% of GDP) in 1960 in India to that in Kenya?
Your response must be concise. 1.46. What is the ratio of the Value added (% of GDP) in 1961 in India to that in Kenya?
Your answer should be compact. 1.44. What is the ratio of the Value added (% of GDP) in 1962 in India to that in Kenya?
Provide a succinct answer. 1.6. What is the ratio of the Value added (% of GDP) in 1963 in India to that in Kenya?
Offer a terse response. 1.58. What is the ratio of the Value added (% of GDP) in 1960 in Indonesia to that in Iran?
Provide a succinct answer. 1.02. What is the ratio of the Value added (% of GDP) of 1961 in Indonesia to that in Iran?
Make the answer very short. 1.16. What is the ratio of the Value added (% of GDP) of 1962 in Indonesia to that in Iran?
Offer a terse response. 0.85. What is the ratio of the Value added (% of GDP) in 1963 in Indonesia to that in Iran?
Give a very brief answer. 0.68. What is the ratio of the Value added (% of GDP) of 1960 in Indonesia to that in Kenya?
Your answer should be compact. 0.98. What is the ratio of the Value added (% of GDP) of 1961 in Indonesia to that in Kenya?
Offer a terse response. 1.1. What is the ratio of the Value added (% of GDP) of 1962 in Indonesia to that in Kenya?
Offer a very short reply. 0.95. What is the ratio of the Value added (% of GDP) in 1963 in Indonesia to that in Kenya?
Your response must be concise. 0.79. What is the ratio of the Value added (% of GDP) of 1960 in Iran to that in Kenya?
Ensure brevity in your answer.  0.96. What is the ratio of the Value added (% of GDP) in 1961 in Iran to that in Kenya?
Your answer should be compact. 0.95. What is the ratio of the Value added (% of GDP) of 1962 in Iran to that in Kenya?
Give a very brief answer. 1.13. What is the ratio of the Value added (% of GDP) in 1963 in Iran to that in Kenya?
Provide a short and direct response. 1.17. What is the difference between the highest and the second highest Value added (% of GDP) of 1960?
Offer a terse response. 1.17. What is the difference between the highest and the second highest Value added (% of GDP) of 1961?
Keep it short and to the point. 1.96. What is the difference between the highest and the second highest Value added (% of GDP) of 1962?
Offer a terse response. 2.42. What is the difference between the highest and the second highest Value added (% of GDP) of 1963?
Provide a succinct answer. 0.31. What is the difference between the highest and the lowest Value added (% of GDP) of 1960?
Give a very brief answer. 4.65. What is the difference between the highest and the lowest Value added (% of GDP) of 1961?
Make the answer very short. 4.92. What is the difference between the highest and the lowest Value added (% of GDP) in 1962?
Offer a very short reply. 6.01. What is the difference between the highest and the lowest Value added (% of GDP) in 1963?
Offer a terse response. 7.4. 